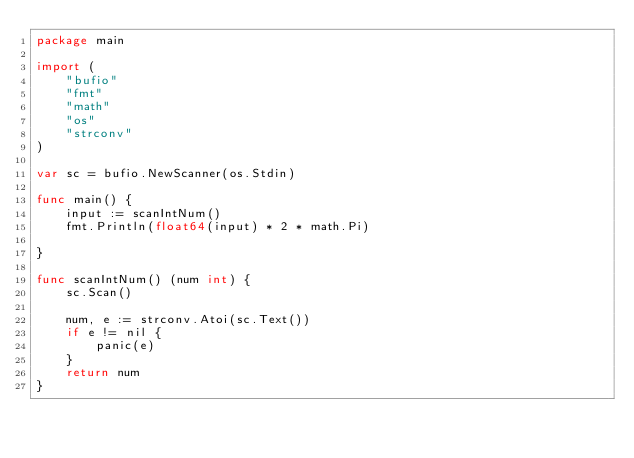Convert code to text. <code><loc_0><loc_0><loc_500><loc_500><_Go_>package main

import (
	"bufio"
	"fmt"
	"math"
	"os"
	"strconv"
)

var sc = bufio.NewScanner(os.Stdin)

func main() {
	input := scanIntNum()
	fmt.Println(float64(input) * 2 * math.Pi)

}

func scanIntNum() (num int) {
	sc.Scan()

	num, e := strconv.Atoi(sc.Text())
	if e != nil {
		panic(e)
	}
	return num
}
</code> 